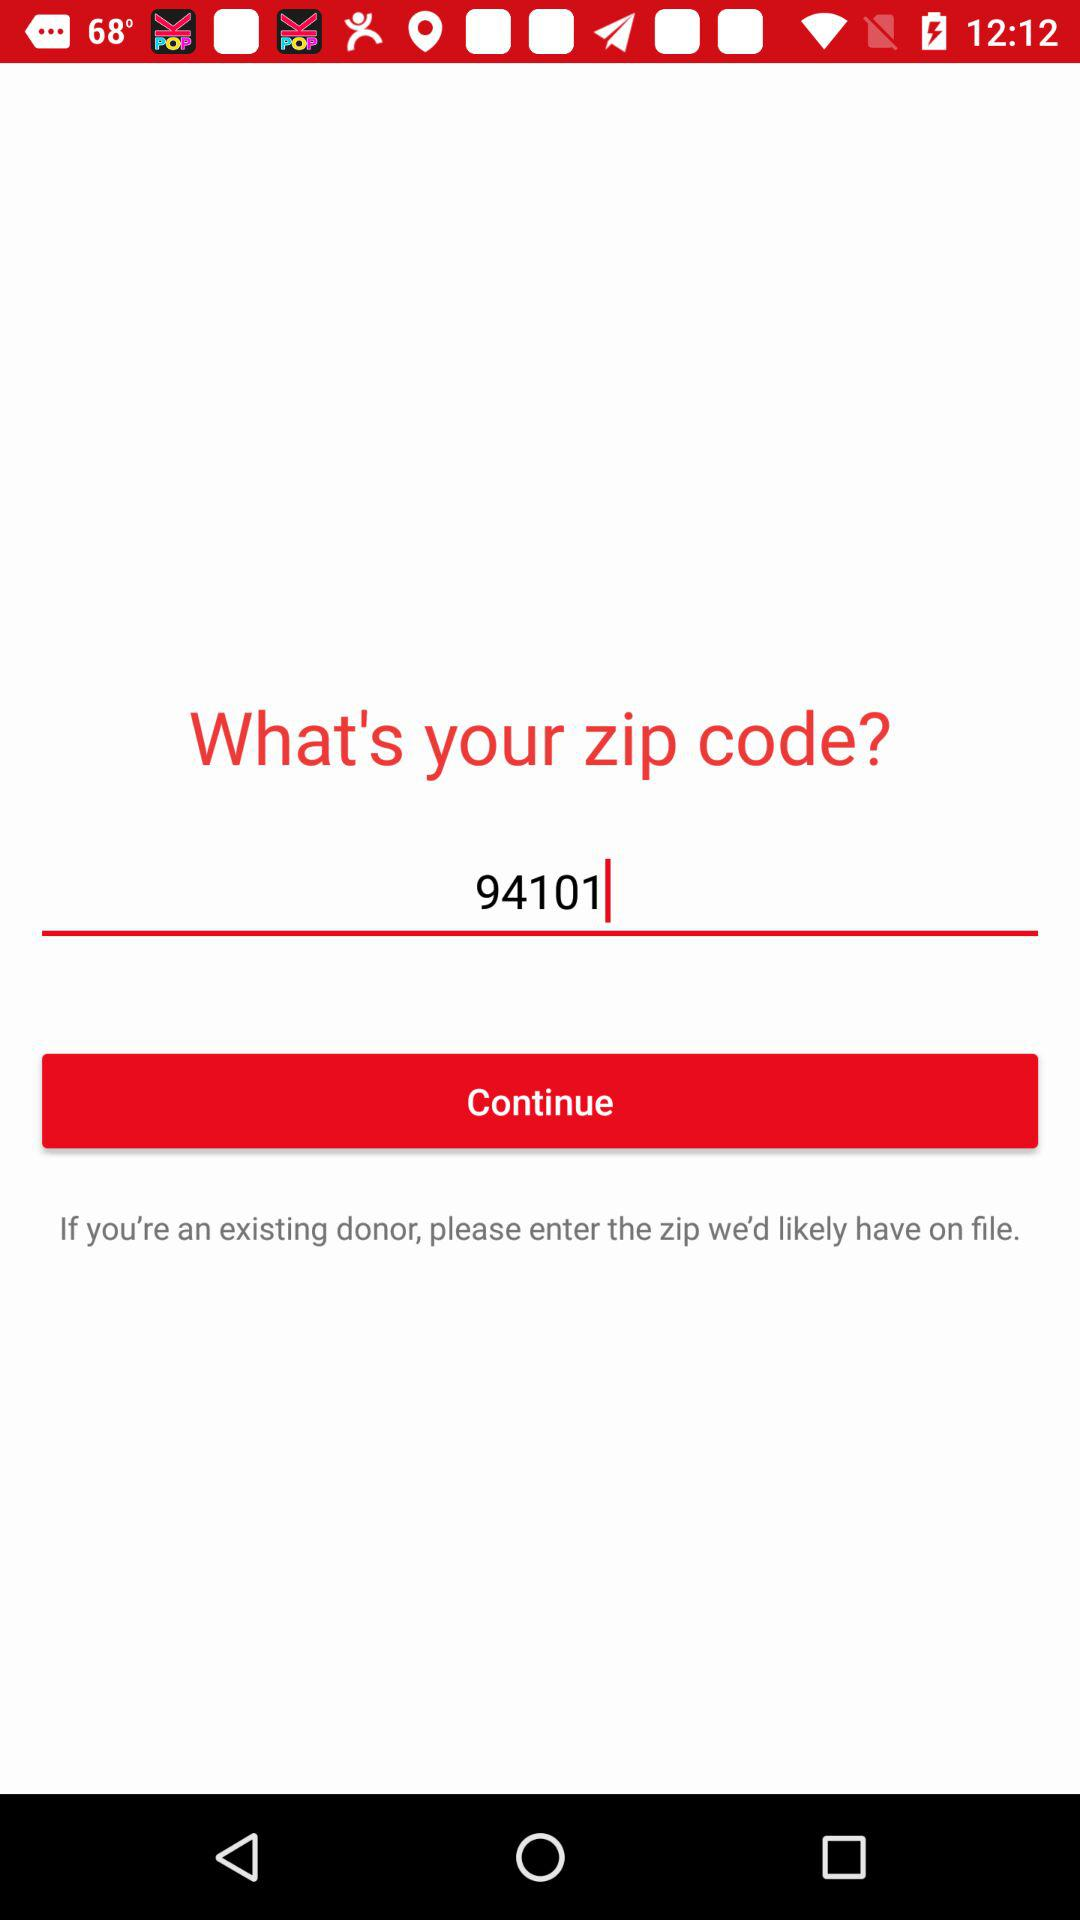What is the zip code? The zip code is 94101. 